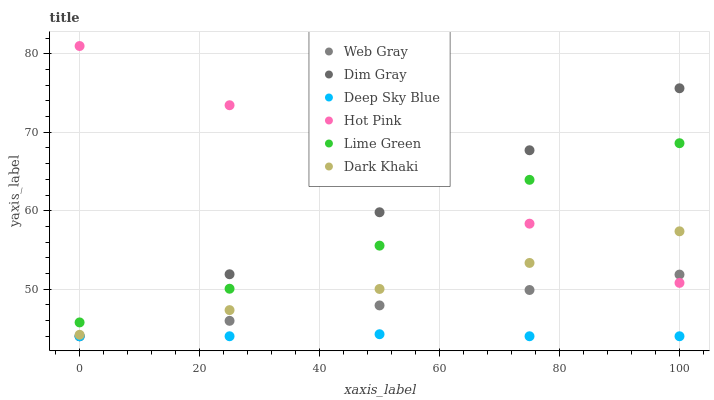Does Deep Sky Blue have the minimum area under the curve?
Answer yes or no. Yes. Does Hot Pink have the maximum area under the curve?
Answer yes or no. Yes. Does Dark Khaki have the minimum area under the curve?
Answer yes or no. No. Does Dark Khaki have the maximum area under the curve?
Answer yes or no. No. Is Hot Pink the smoothest?
Answer yes or no. Yes. Is Lime Green the roughest?
Answer yes or no. Yes. Is Dark Khaki the smoothest?
Answer yes or no. No. Is Dark Khaki the roughest?
Answer yes or no. No. Does Dim Gray have the lowest value?
Answer yes or no. Yes. Does Dark Khaki have the lowest value?
Answer yes or no. No. Does Hot Pink have the highest value?
Answer yes or no. Yes. Does Dark Khaki have the highest value?
Answer yes or no. No. Is Web Gray less than Lime Green?
Answer yes or no. Yes. Is Lime Green greater than Deep Sky Blue?
Answer yes or no. Yes. Does Deep Sky Blue intersect Dim Gray?
Answer yes or no. Yes. Is Deep Sky Blue less than Dim Gray?
Answer yes or no. No. Is Deep Sky Blue greater than Dim Gray?
Answer yes or no. No. Does Web Gray intersect Lime Green?
Answer yes or no. No. 